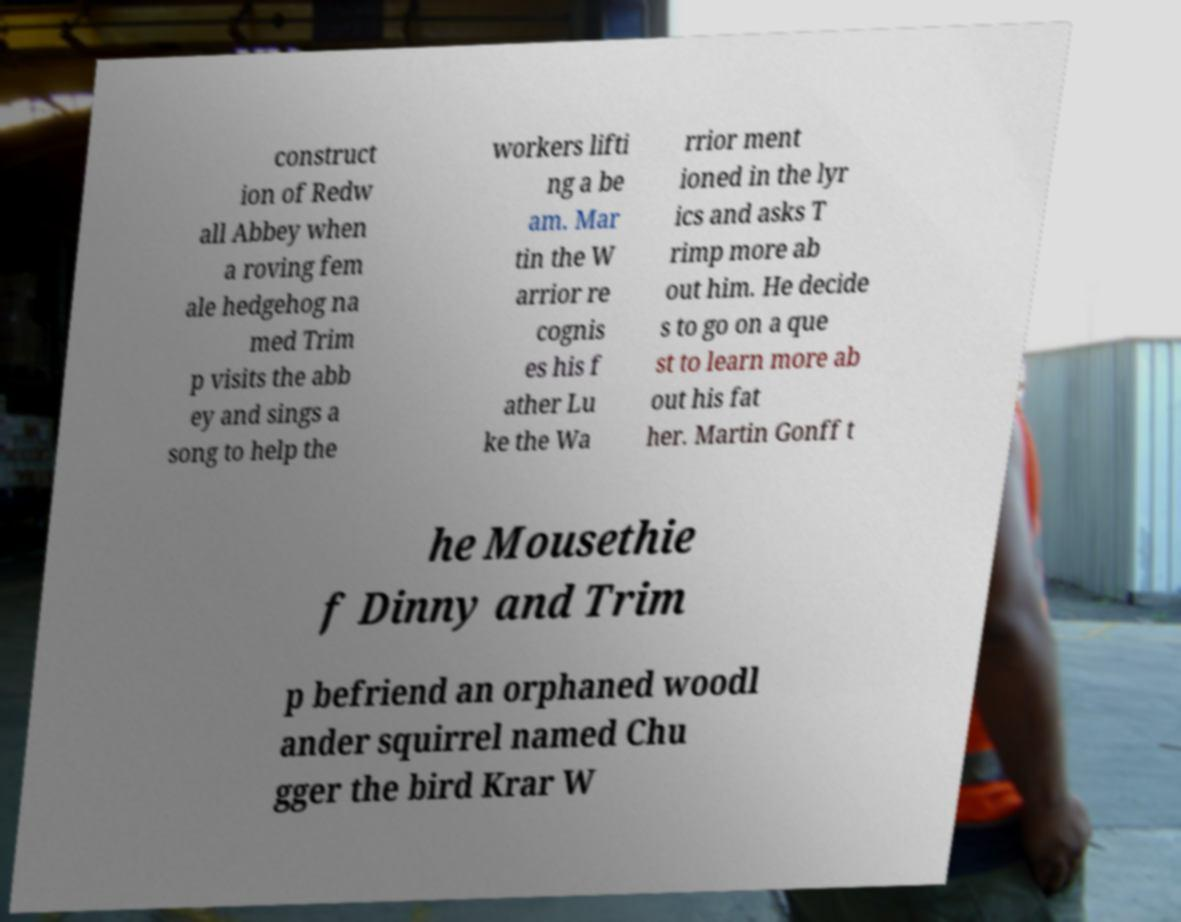Please identify and transcribe the text found in this image. construct ion of Redw all Abbey when a roving fem ale hedgehog na med Trim p visits the abb ey and sings a song to help the workers lifti ng a be am. Mar tin the W arrior re cognis es his f ather Lu ke the Wa rrior ment ioned in the lyr ics and asks T rimp more ab out him. He decide s to go on a que st to learn more ab out his fat her. Martin Gonff t he Mousethie f Dinny and Trim p befriend an orphaned woodl ander squirrel named Chu gger the bird Krar W 